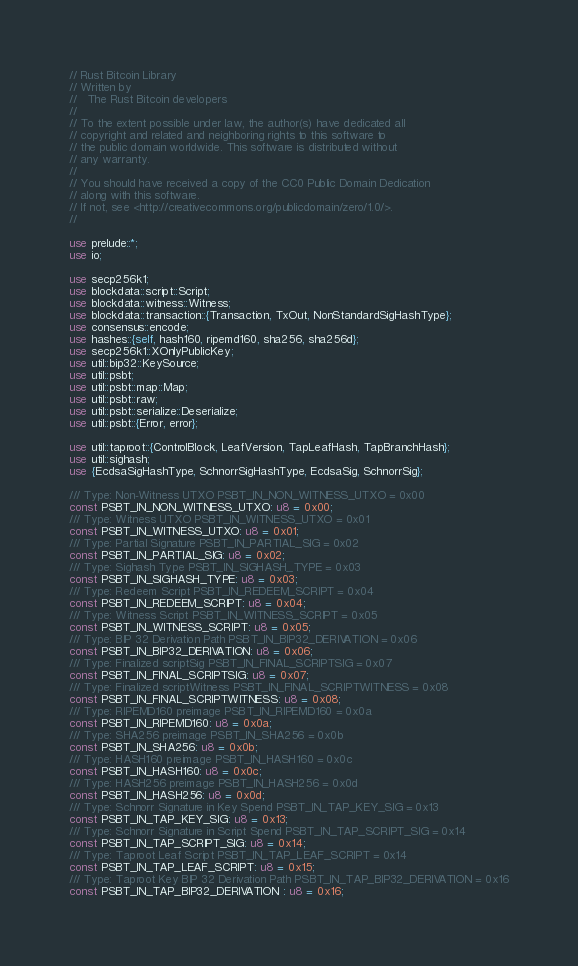<code> <loc_0><loc_0><loc_500><loc_500><_Rust_>// Rust Bitcoin Library
// Written by
//   The Rust Bitcoin developers
//
// To the extent possible under law, the author(s) have dedicated all
// copyright and related and neighboring rights to this software to
// the public domain worldwide. This software is distributed without
// any warranty.
//
// You should have received a copy of the CC0 Public Domain Dedication
// along with this software.
// If not, see <http://creativecommons.org/publicdomain/zero/1.0/>.
//

use prelude::*;
use io;

use secp256k1;
use blockdata::script::Script;
use blockdata::witness::Witness;
use blockdata::transaction::{Transaction, TxOut, NonStandardSigHashType};
use consensus::encode;
use hashes::{self, hash160, ripemd160, sha256, sha256d};
use secp256k1::XOnlyPublicKey;
use util::bip32::KeySource;
use util::psbt;
use util::psbt::map::Map;
use util::psbt::raw;
use util::psbt::serialize::Deserialize;
use util::psbt::{Error, error};

use util::taproot::{ControlBlock, LeafVersion, TapLeafHash, TapBranchHash};
use util::sighash;
use {EcdsaSigHashType, SchnorrSigHashType, EcdsaSig, SchnorrSig};

/// Type: Non-Witness UTXO PSBT_IN_NON_WITNESS_UTXO = 0x00
const PSBT_IN_NON_WITNESS_UTXO: u8 = 0x00;
/// Type: Witness UTXO PSBT_IN_WITNESS_UTXO = 0x01
const PSBT_IN_WITNESS_UTXO: u8 = 0x01;
/// Type: Partial Signature PSBT_IN_PARTIAL_SIG = 0x02
const PSBT_IN_PARTIAL_SIG: u8 = 0x02;
/// Type: Sighash Type PSBT_IN_SIGHASH_TYPE = 0x03
const PSBT_IN_SIGHASH_TYPE: u8 = 0x03;
/// Type: Redeem Script PSBT_IN_REDEEM_SCRIPT = 0x04
const PSBT_IN_REDEEM_SCRIPT: u8 = 0x04;
/// Type: Witness Script PSBT_IN_WITNESS_SCRIPT = 0x05
const PSBT_IN_WITNESS_SCRIPT: u8 = 0x05;
/// Type: BIP 32 Derivation Path PSBT_IN_BIP32_DERIVATION = 0x06
const PSBT_IN_BIP32_DERIVATION: u8 = 0x06;
/// Type: Finalized scriptSig PSBT_IN_FINAL_SCRIPTSIG = 0x07
const PSBT_IN_FINAL_SCRIPTSIG: u8 = 0x07;
/// Type: Finalized scriptWitness PSBT_IN_FINAL_SCRIPTWITNESS = 0x08
const PSBT_IN_FINAL_SCRIPTWITNESS: u8 = 0x08;
/// Type: RIPEMD160 preimage PSBT_IN_RIPEMD160 = 0x0a
const PSBT_IN_RIPEMD160: u8 = 0x0a;
/// Type: SHA256 preimage PSBT_IN_SHA256 = 0x0b
const PSBT_IN_SHA256: u8 = 0x0b;
/// Type: HASH160 preimage PSBT_IN_HASH160 = 0x0c
const PSBT_IN_HASH160: u8 = 0x0c;
/// Type: HASH256 preimage PSBT_IN_HASH256 = 0x0d
const PSBT_IN_HASH256: u8 = 0x0d;
/// Type: Schnorr Signature in Key Spend PSBT_IN_TAP_KEY_SIG = 0x13
const PSBT_IN_TAP_KEY_SIG: u8 = 0x13;
/// Type: Schnorr Signature in Script Spend PSBT_IN_TAP_SCRIPT_SIG = 0x14
const PSBT_IN_TAP_SCRIPT_SIG: u8 = 0x14;
/// Type: Taproot Leaf Script PSBT_IN_TAP_LEAF_SCRIPT = 0x14
const PSBT_IN_TAP_LEAF_SCRIPT: u8 = 0x15;
/// Type: Taproot Key BIP 32 Derivation Path PSBT_IN_TAP_BIP32_DERIVATION = 0x16
const PSBT_IN_TAP_BIP32_DERIVATION : u8 = 0x16;</code> 